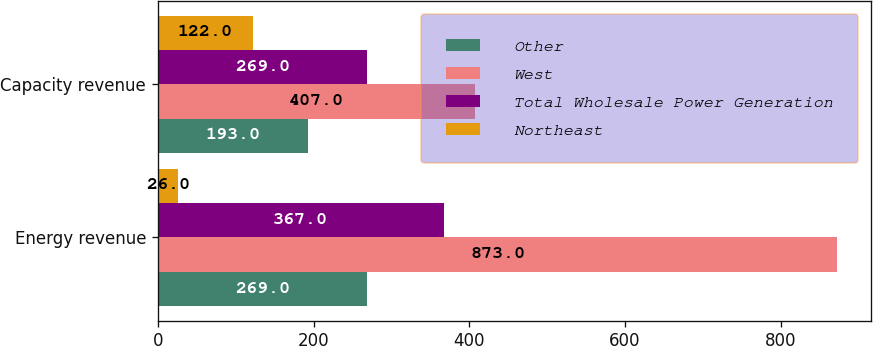Convert chart. <chart><loc_0><loc_0><loc_500><loc_500><stacked_bar_chart><ecel><fcel>Energy revenue<fcel>Capacity revenue<nl><fcel>Other<fcel>269<fcel>193<nl><fcel>West<fcel>873<fcel>407<nl><fcel>Total Wholesale Power Generation<fcel>367<fcel>269<nl><fcel>Northeast<fcel>26<fcel>122<nl></chart> 